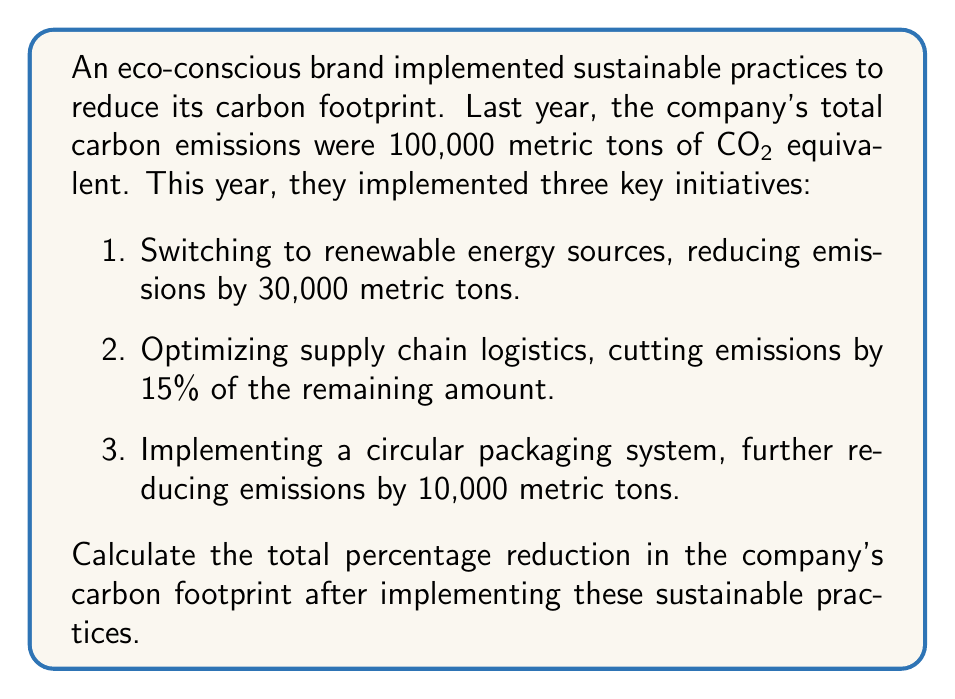Can you solve this math problem? To solve this problem, we'll follow these steps:

1. Calculate the reduction from switching to renewable energy:
   $$100,000 - 30,000 = 70,000$$ metric tons remaining

2. Calculate the reduction from optimizing supply chain logistics:
   $$70,000 \times 15\% = 10,500$$ metric tons
   $$70,000 - 10,500 = 59,500$$ metric tons remaining

3. Apply the reduction from the circular packaging system:
   $$59,500 - 10,000 = 49,500$$ metric tons final emissions

4. Calculate the total reduction:
   $$100,000 - 49,500 = 50,500$$ metric tons total reduction

5. Calculate the percentage reduction:
   $$\text{Percentage reduction} = \frac{\text{Total reduction}}{\text{Original emissions}} \times 100\%$$
   $$= \frac{50,500}{100,000} \times 100\% = 50.5\%$$

Therefore, the total percentage reduction in the company's carbon footprint is 50.5%.
Answer: 50.5% 